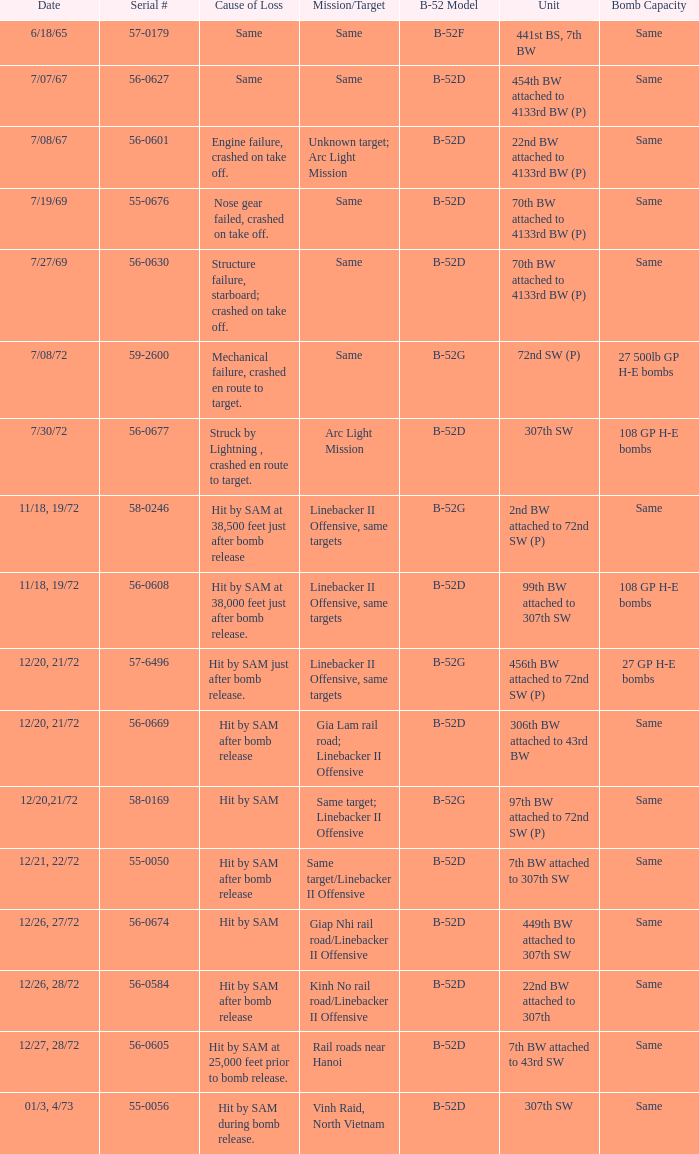When 441st bs, 7th bw is the unit what is the b-52 model? B-52F. 